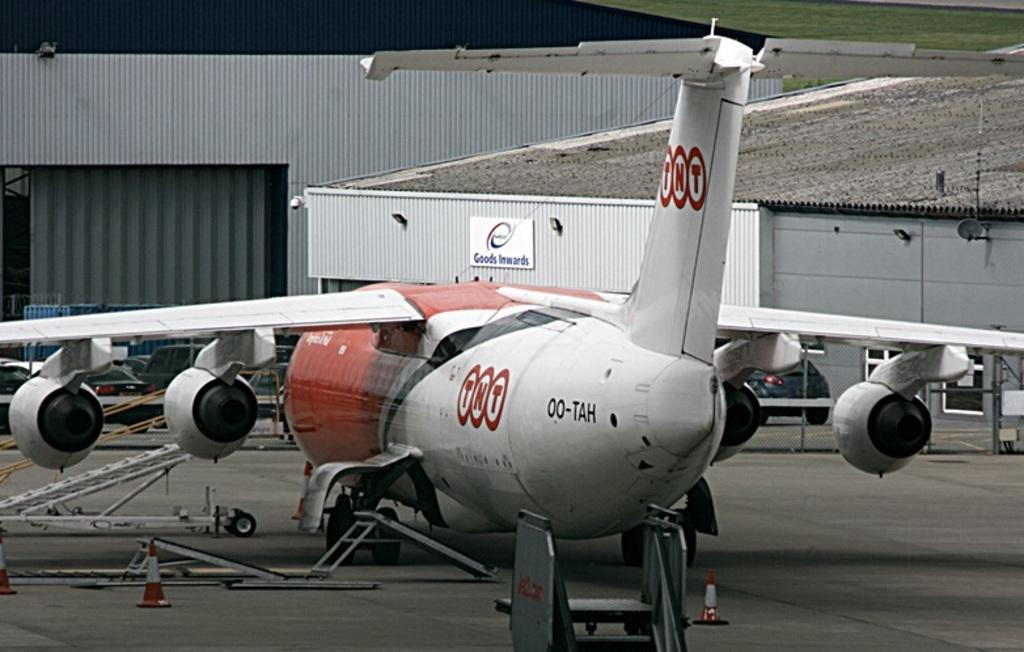What type of vegetation can be seen in the background of the image? There is green grass in the background of the image. What structures are visible in the background of the image? There are sheds in the background of the image. What is the main subject of the image? There is an airplane in the image. What objects are present in the image? There are objects in the image, but their specific nature is not mentioned in the facts. What is at the bottom portion of the image? There is a road at the bottom portion of the image. What safety devices are present on the road? Traffic cones are present on the road. What type of peace symbol can be seen on the flag in the image? There is no flag present in the image, so it is not possible to answer that question. 